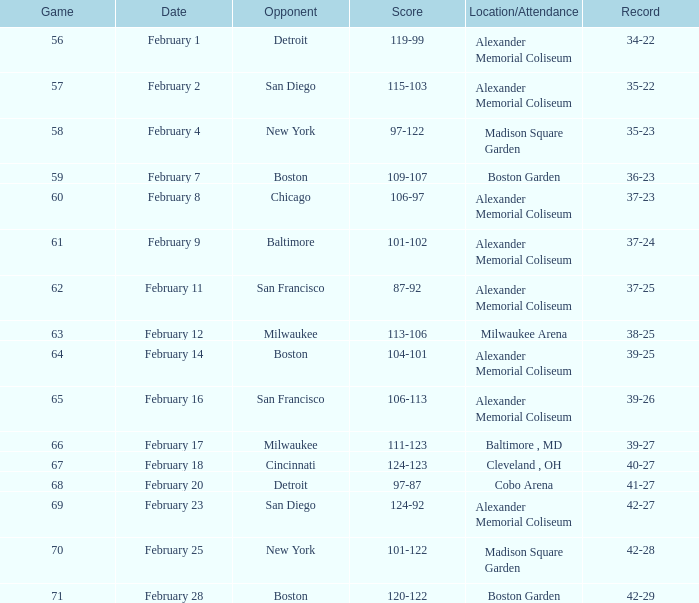Which game number had a score of 87-92? 62.0. 